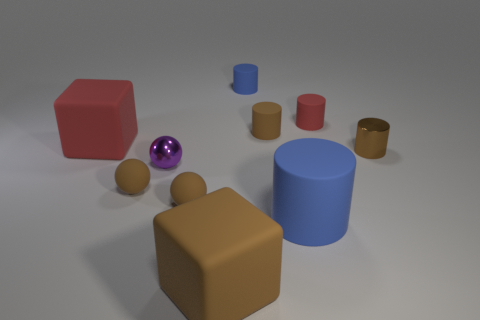Subtract all red matte cylinders. How many cylinders are left? 4 Subtract 2 cylinders. How many cylinders are left? 3 Subtract all red cylinders. How many cylinders are left? 4 Subtract all red cylinders. Subtract all yellow balls. How many cylinders are left? 4 Subtract all blocks. How many objects are left? 8 Add 6 metal cylinders. How many metal cylinders are left? 7 Add 8 small blue matte things. How many small blue matte things exist? 9 Subtract 0 yellow cubes. How many objects are left? 10 Subtract all large rubber things. Subtract all tiny brown matte balls. How many objects are left? 5 